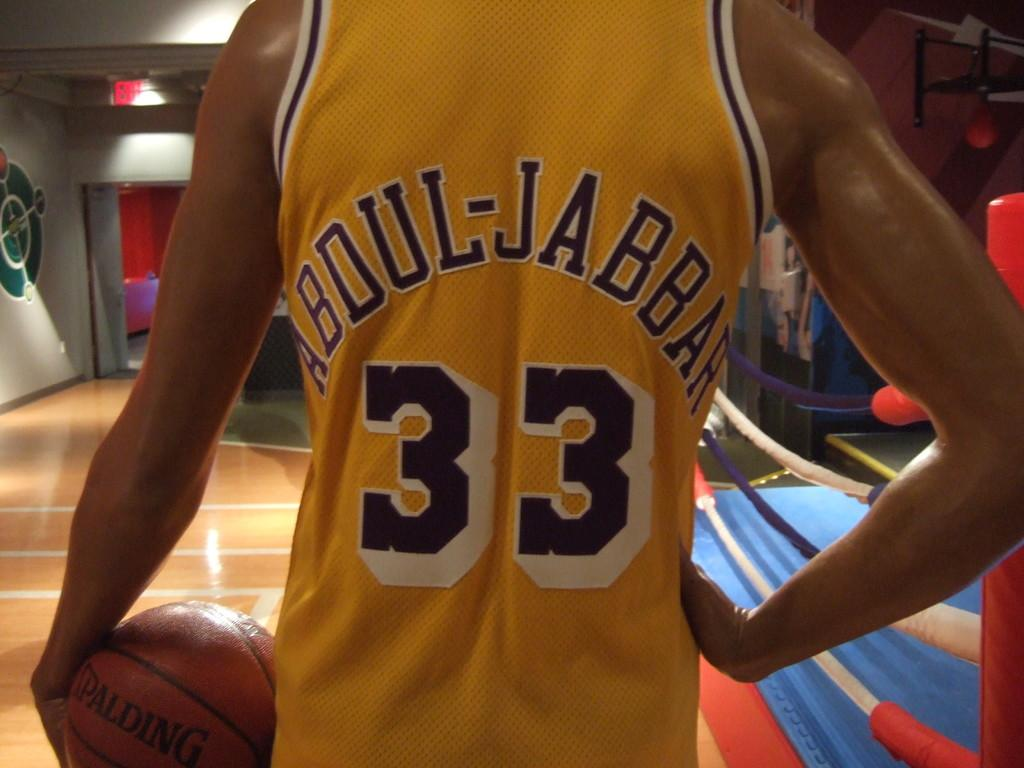<image>
Provide a brief description of the given image. a person in a Abdul-Jabbar 33 jersey holds a basketball 